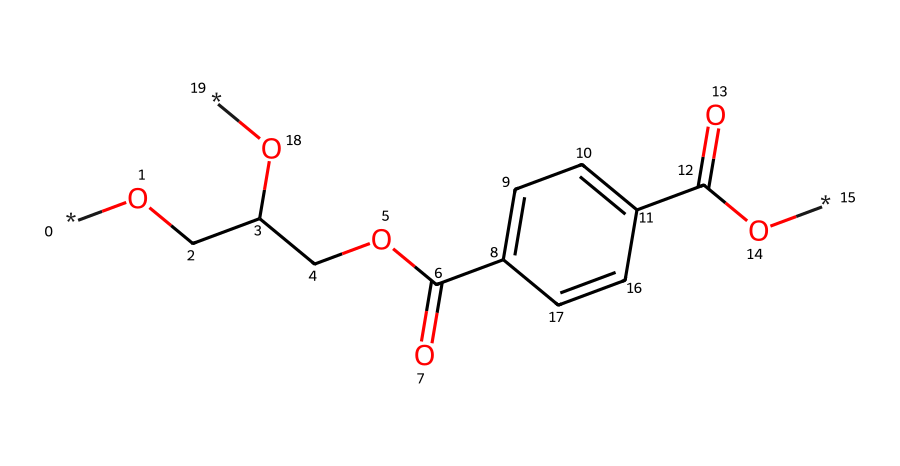What is the name of this polymer? The provided SMILES notation refers to polyethylene terephthalate, commonly known as PET, which is widely used in making plastic water bottles.
Answer: polyethylene terephthalate How many carbon atoms are in this structure? By analyzing the SMILES representation, we can identify the carbon atoms indicated in the structure. There are a total of 10 carbon atoms in PET's repeating unit.
Answer: 10 What functional groups are present? The structure contains ester and hydroxyl functional groups, since it includes parts of carboxylic acid (−COOH) and alcohol (−OH) groups, typical for PET.
Answer: ester, hydroxyl What is the degree of polymerization for typical PET? The degree of polymerization refers to the number of monomer units in a polymer chain. For PET, this is typically in the range of 100-200, depending on the specific application.
Answer: 100-200 What type of polymerization is involved in the formation of PET? PET is synthesized through a process called condensation polymerization, where monomers react to eliminate small molecules, often water, forming the polymer.
Answer: condensation What is the impact of the aromatic ring present in PET? The presence of the aromatic ring in PET contributes to its rigidity and thermal stability, enhancing the overall properties of the polymer for various applications.
Answer: rigidity, thermal stability 